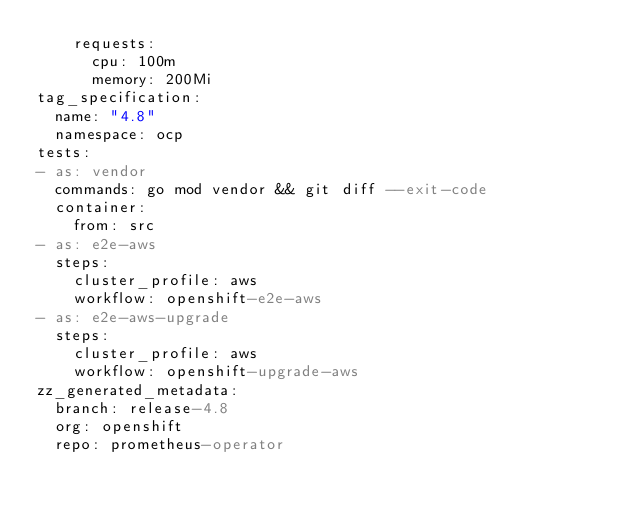<code> <loc_0><loc_0><loc_500><loc_500><_YAML_>    requests:
      cpu: 100m
      memory: 200Mi
tag_specification:
  name: "4.8"
  namespace: ocp
tests:
- as: vendor
  commands: go mod vendor && git diff --exit-code
  container:
    from: src
- as: e2e-aws
  steps:
    cluster_profile: aws
    workflow: openshift-e2e-aws
- as: e2e-aws-upgrade
  steps:
    cluster_profile: aws
    workflow: openshift-upgrade-aws
zz_generated_metadata:
  branch: release-4.8
  org: openshift
  repo: prometheus-operator
</code> 